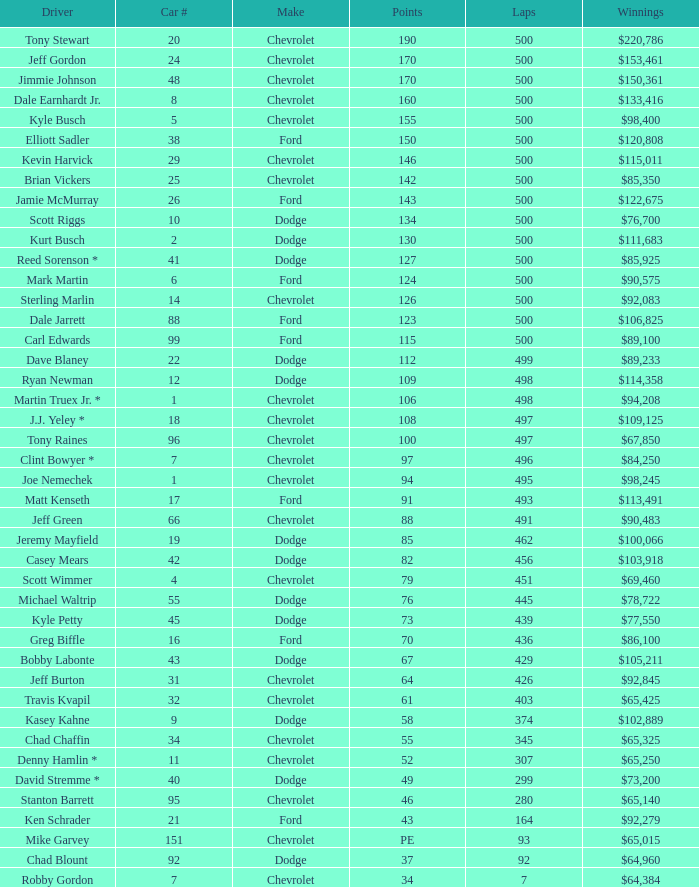What is the average car number of all the drivers with 109 points? 12.0. 